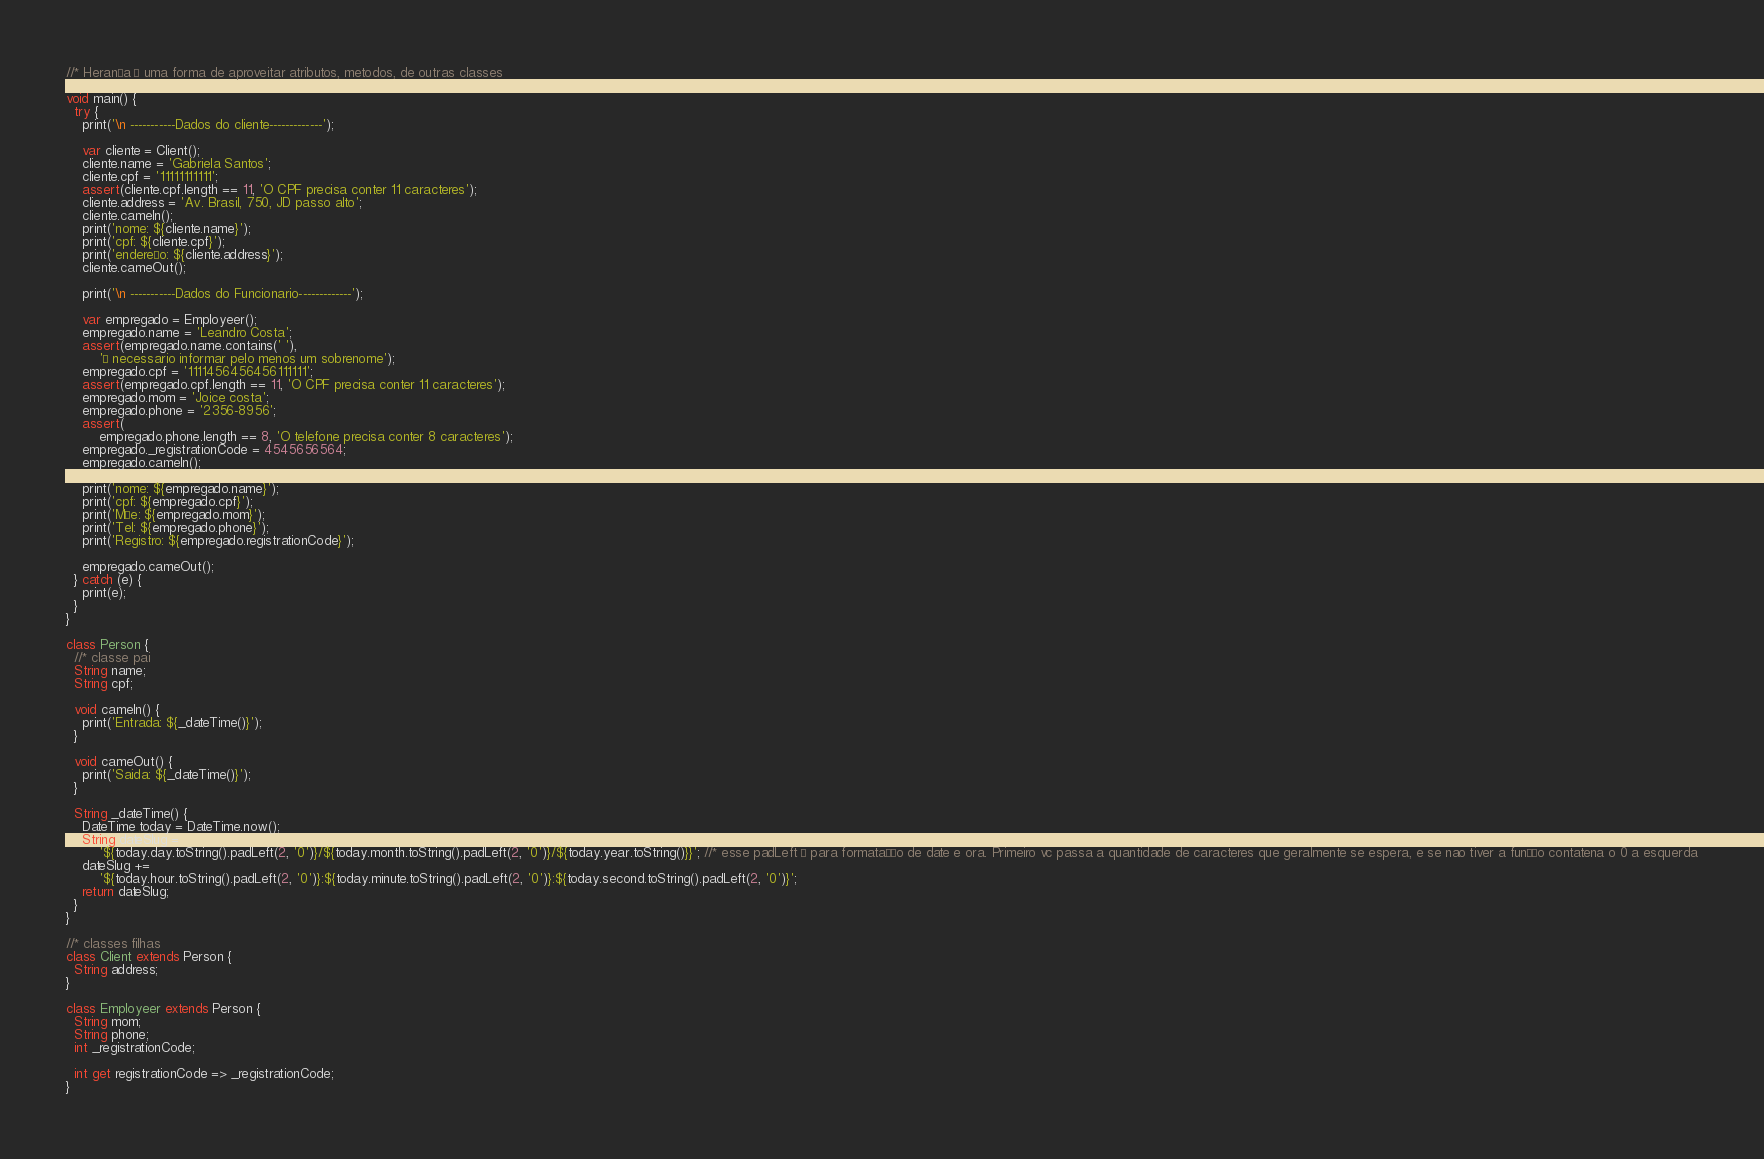<code> <loc_0><loc_0><loc_500><loc_500><_Dart_>//* Herança é uma forma de aproveitar atributos, metodos, de outras classes

void main() {
  try {
    print('\n -----------Dados do cliente-------------');

    var cliente = Client();
    cliente.name = 'Gabriela Santos';
    cliente.cpf = '11111111111';
    assert(cliente.cpf.length == 11, 'O CPF precisa conter 11 caracteres');
    cliente.address = 'Av. Brasil, 750, JD passo alto';
    cliente.cameIn();
    print('nome: ${cliente.name}');
    print('cpf: ${cliente.cpf}');
    print('endereço: ${cliente.address}');
    cliente.cameOut();

    print('\n -----------Dados do Funcionario-------------');

    var empregado = Employeer();
    empregado.name = 'Leandro Costa';
    assert(empregado.name.contains(' '),
        'É necessario informar pelo menos um sobrenome');
    empregado.cpf = '1111456456456111111';
    assert(empregado.cpf.length == 11, 'O CPF precisa conter 11 caracteres');
    empregado.mom = 'Joice costa';
    empregado.phone = '2356-8956';
    assert(
        empregado.phone.length == 8, 'O telefone precisa conter 8 caracteres');
    empregado._registrationCode = 4545656564;
    empregado.cameIn();

    print('nome: ${empregado.name}');
    print('cpf: ${empregado.cpf}');
    print('Mãe: ${empregado.mom}');
    print('Tel: ${empregado.phone}');
    print('Registro: ${empregado.registrationCode}');

    empregado.cameOut();
  } catch (e) {
    print(e);
  }
}

class Person {
  //* classe pai
  String name;
  String cpf;

  void cameIn() {
    print('Entrada: ${_dateTime()}');
  }

  void cameOut() {
    print('Saida: ${_dateTime()}');
  }

  String _dateTime() {
    DateTime today = DateTime.now();
    String dateSlug =
        '${today.day.toString().padLeft(2, '0')}/${today.month.toString().padLeft(2, '0')}/${today.year.toString()}}'; //* esse padLeft é para formatação de date e ora. Primeiro vc passa a quantidade de caracteres que geralmente se espera, e se nao tiver a função contatena o 0 a esquerda
    dateSlug +=
        '${today.hour.toString().padLeft(2, '0')}:${today.minute.toString().padLeft(2, '0')}:${today.second.toString().padLeft(2, '0')}';
    return dateSlug;
  }
}

//* classes filhas
class Client extends Person {
  String address;
}

class Employeer extends Person {
  String mom;
  String phone;
  int _registrationCode;

  int get registrationCode => _registrationCode;
}
</code> 